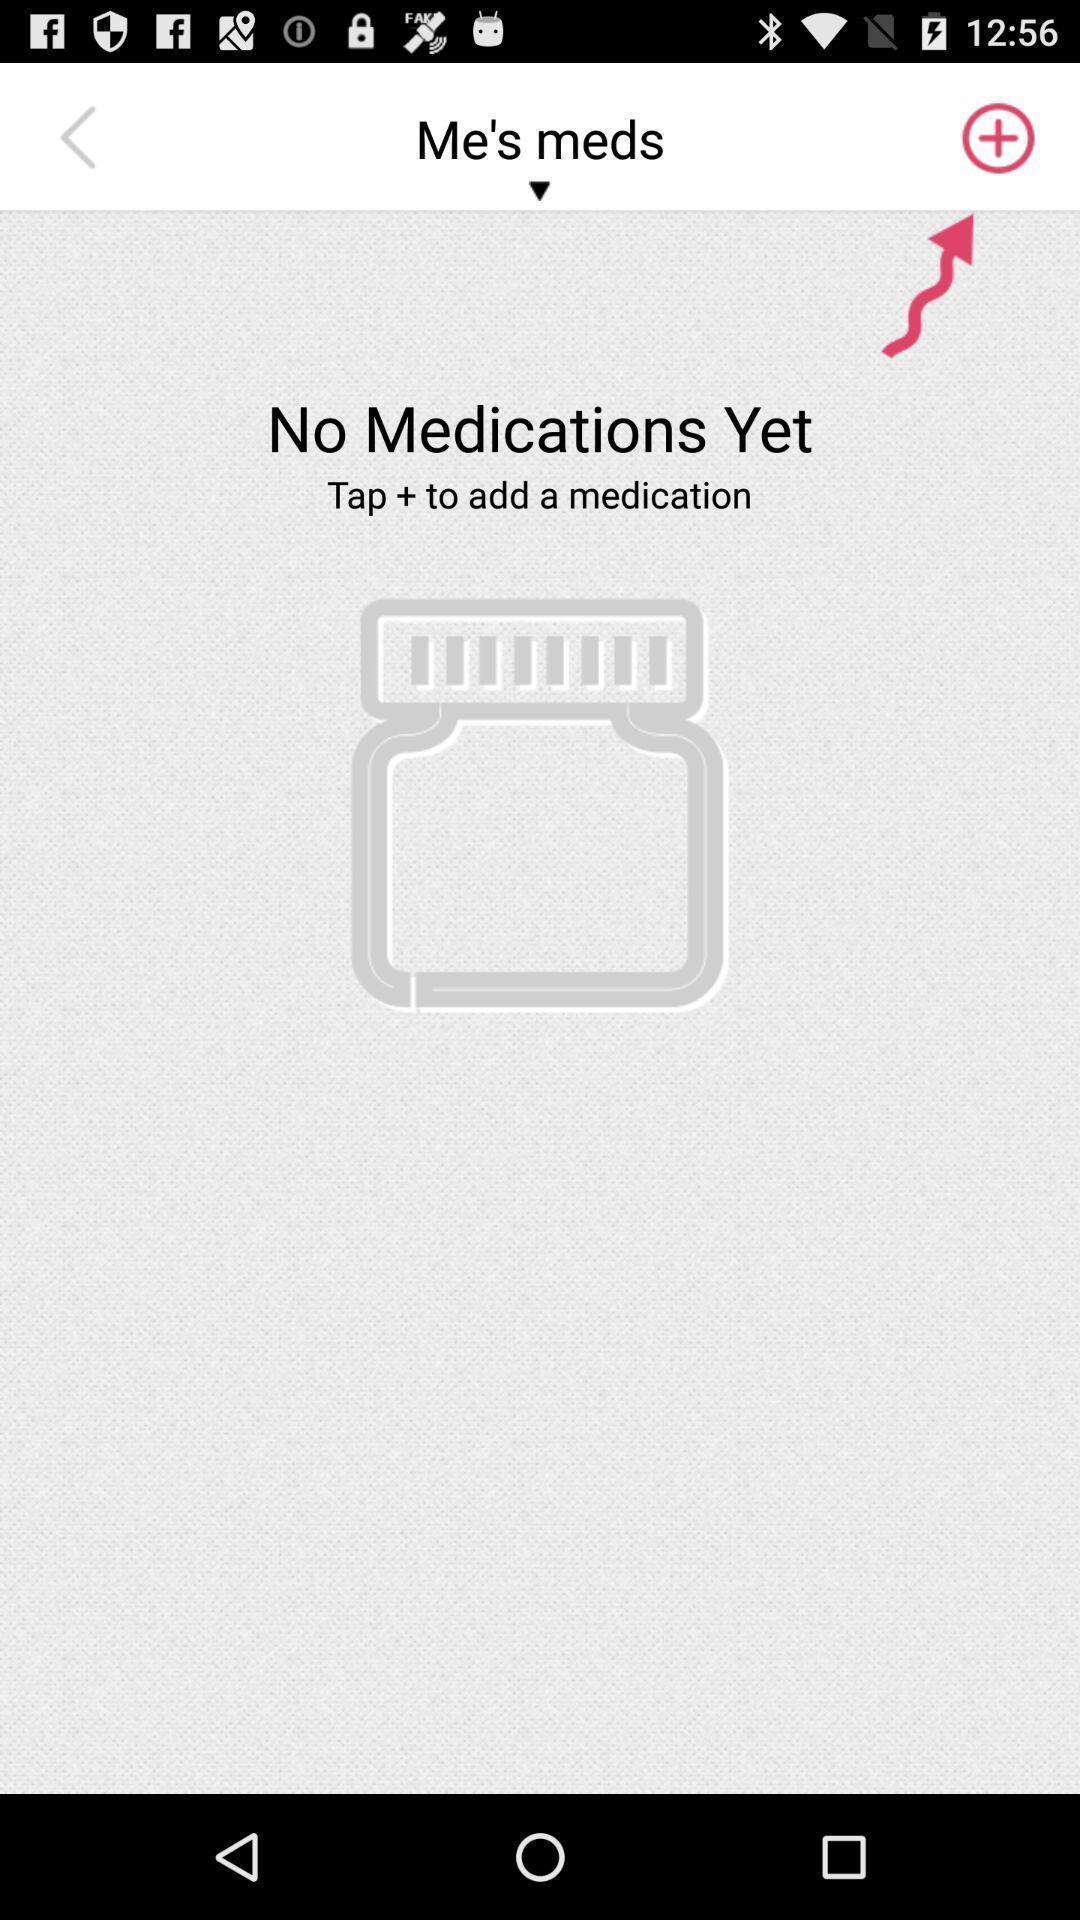Provide a detailed account of this screenshot. Page showing various options of app. 